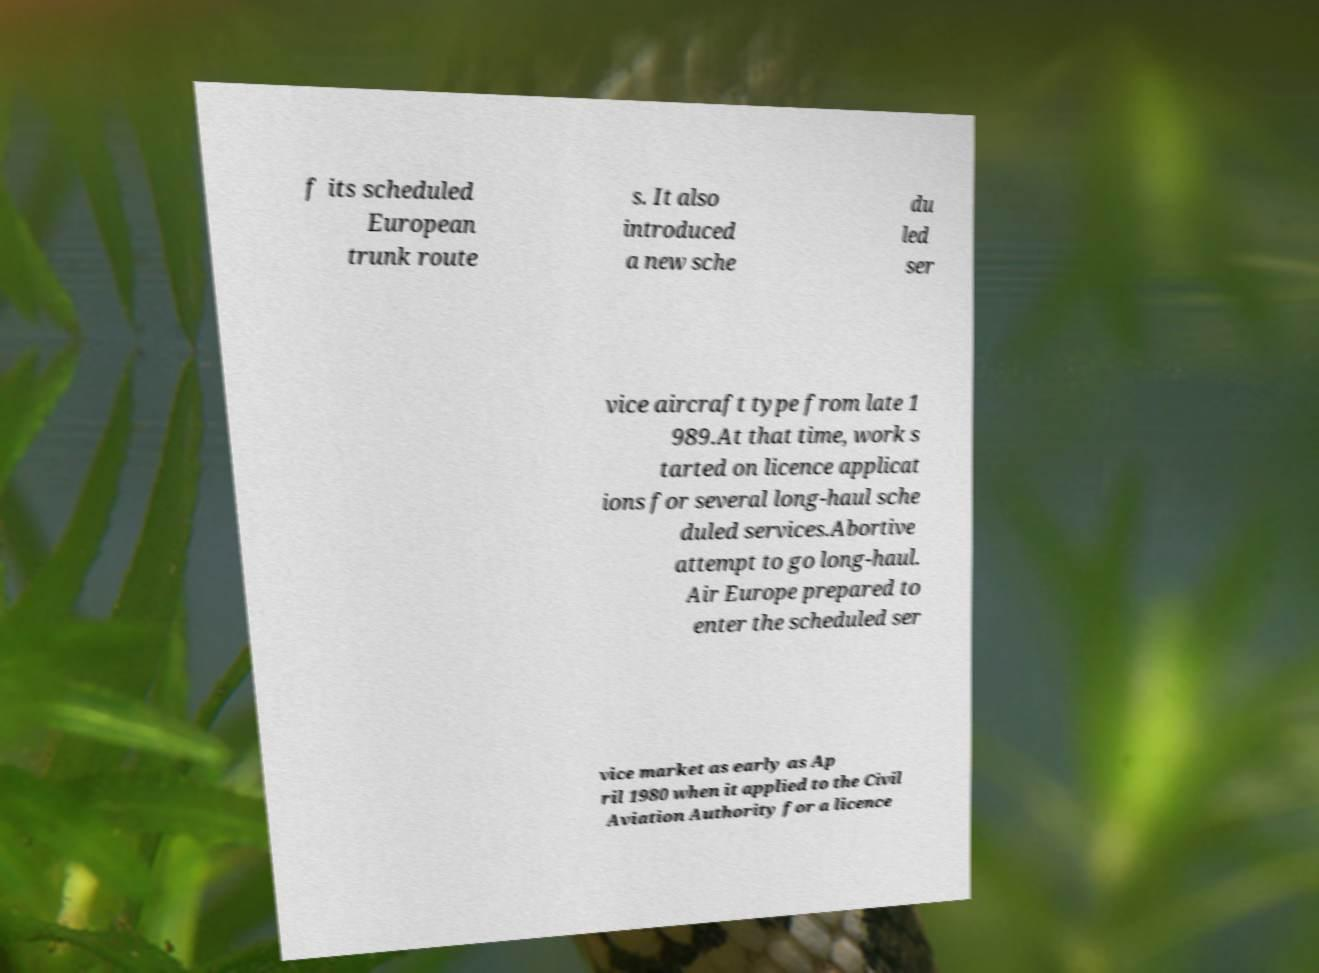I need the written content from this picture converted into text. Can you do that? f its scheduled European trunk route s. It also introduced a new sche du led ser vice aircraft type from late 1 989.At that time, work s tarted on licence applicat ions for several long-haul sche duled services.Abortive attempt to go long-haul. Air Europe prepared to enter the scheduled ser vice market as early as Ap ril 1980 when it applied to the Civil Aviation Authority for a licence 